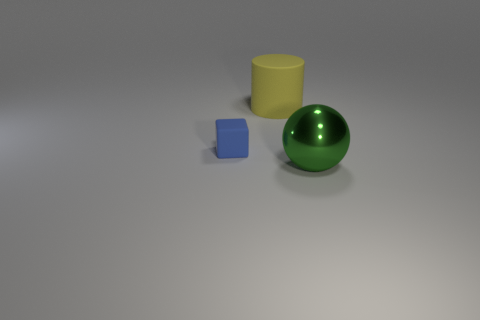Is the number of large things right of the big yellow matte thing greater than the number of tiny blue matte cubes behind the tiny block?
Your answer should be very brief. Yes. There is a thing in front of the rubber block; does it have the same size as the yellow cylinder?
Your answer should be compact. Yes. How many blue blocks are to the right of the thing that is to the right of the thing behind the blue cube?
Keep it short and to the point. 0. There is a object that is to the right of the small cube and in front of the yellow rubber cylinder; what size is it?
Offer a terse response. Large. How many other things are there of the same shape as the large matte object?
Your answer should be compact. 0. There is a green thing; what number of green metal things are on the left side of it?
Give a very brief answer. 0. Are there fewer yellow cylinders that are to the right of the large green sphere than yellow matte cylinders behind the blue cube?
Your response must be concise. Yes. The matte thing on the right side of the object left of the rubber thing that is right of the matte cube is what shape?
Make the answer very short. Cylinder. There is a object that is both on the right side of the small blue matte object and behind the metallic thing; what is its shape?
Make the answer very short. Cylinder. Is there a large yellow cylinder that has the same material as the tiny object?
Make the answer very short. Yes. 